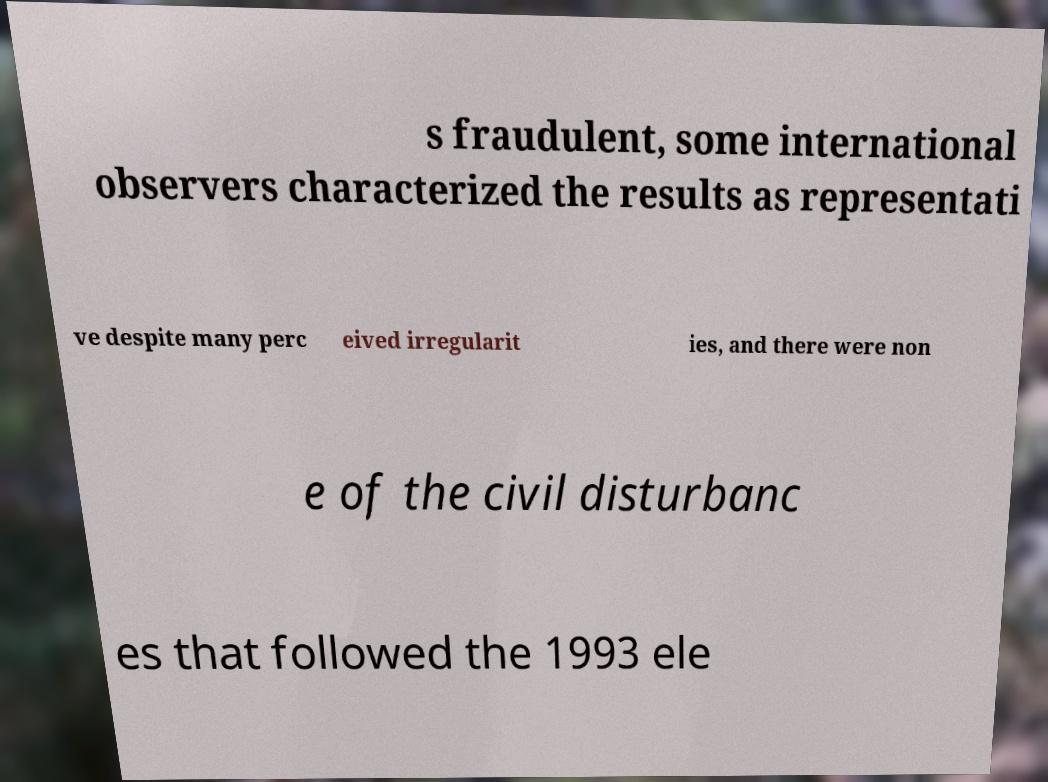What messages or text are displayed in this image? I need them in a readable, typed format. s fraudulent, some international observers characterized the results as representati ve despite many perc eived irregularit ies, and there were non e of the civil disturbanc es that followed the 1993 ele 